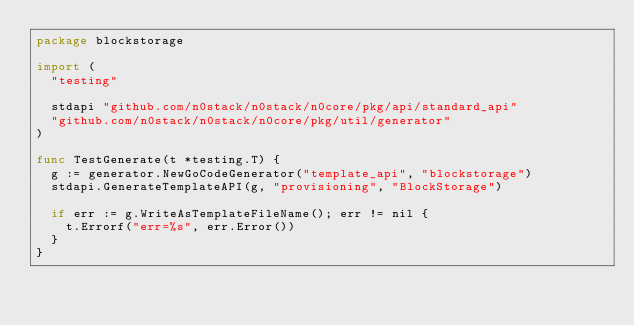<code> <loc_0><loc_0><loc_500><loc_500><_Go_>package blockstorage

import (
	"testing"

	stdapi "github.com/n0stack/n0stack/n0core/pkg/api/standard_api"
	"github.com/n0stack/n0stack/n0core/pkg/util/generator"
)

func TestGenerate(t *testing.T) {
	g := generator.NewGoCodeGenerator("template_api", "blockstorage")
	stdapi.GenerateTemplateAPI(g, "provisioning", "BlockStorage")

	if err := g.WriteAsTemplateFileName(); err != nil {
		t.Errorf("err=%s", err.Error())
	}
}
</code> 